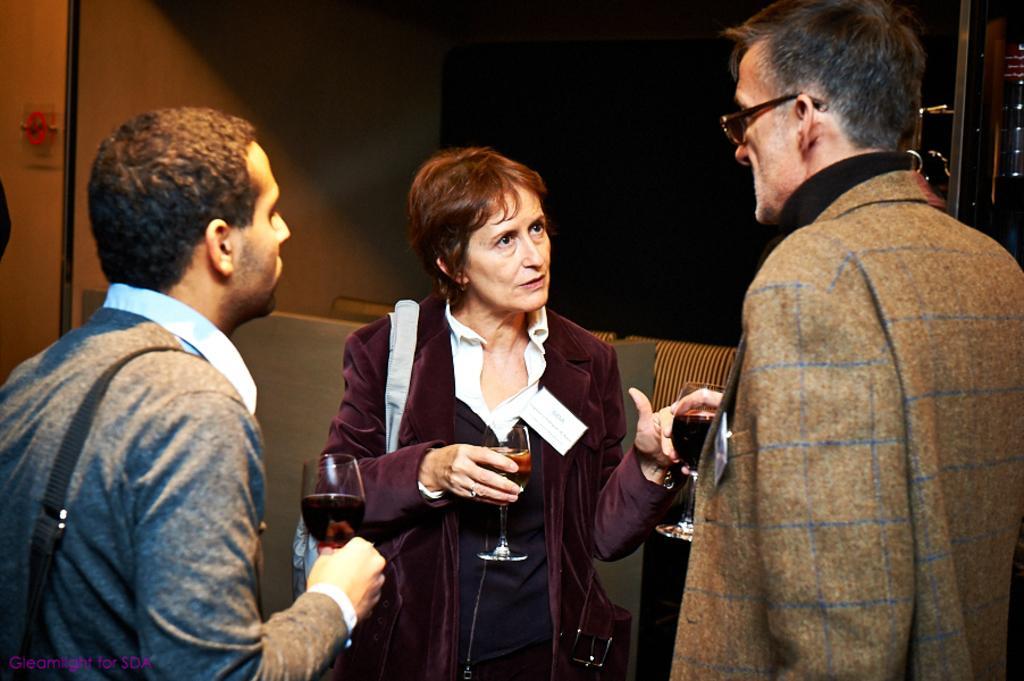Describe this image in one or two sentences. In the image there are two men and women standing in front of each other, all are holding wine glasses, all wearing suits, in the back it seems to be a sofa, this is clicked inside a room. 